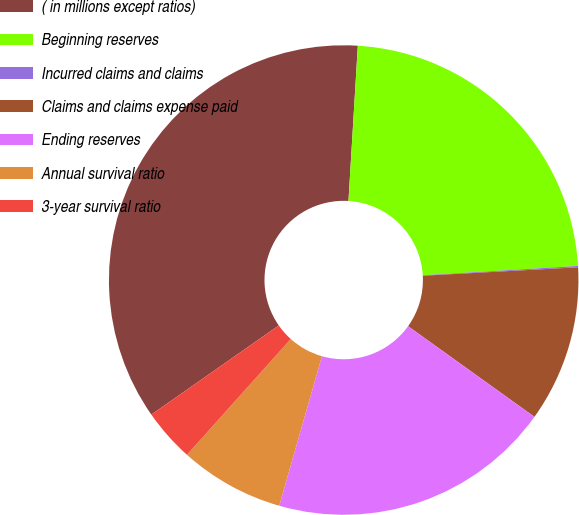<chart> <loc_0><loc_0><loc_500><loc_500><pie_chart><fcel>( in millions except ratios)<fcel>Beginning reserves<fcel>Incurred claims and claims<fcel>Claims and claims expense paid<fcel>Ending reserves<fcel>Annual survival ratio<fcel>3-year survival ratio<nl><fcel>35.68%<fcel>23.09%<fcel>0.09%<fcel>10.77%<fcel>19.53%<fcel>7.21%<fcel>3.65%<nl></chart> 